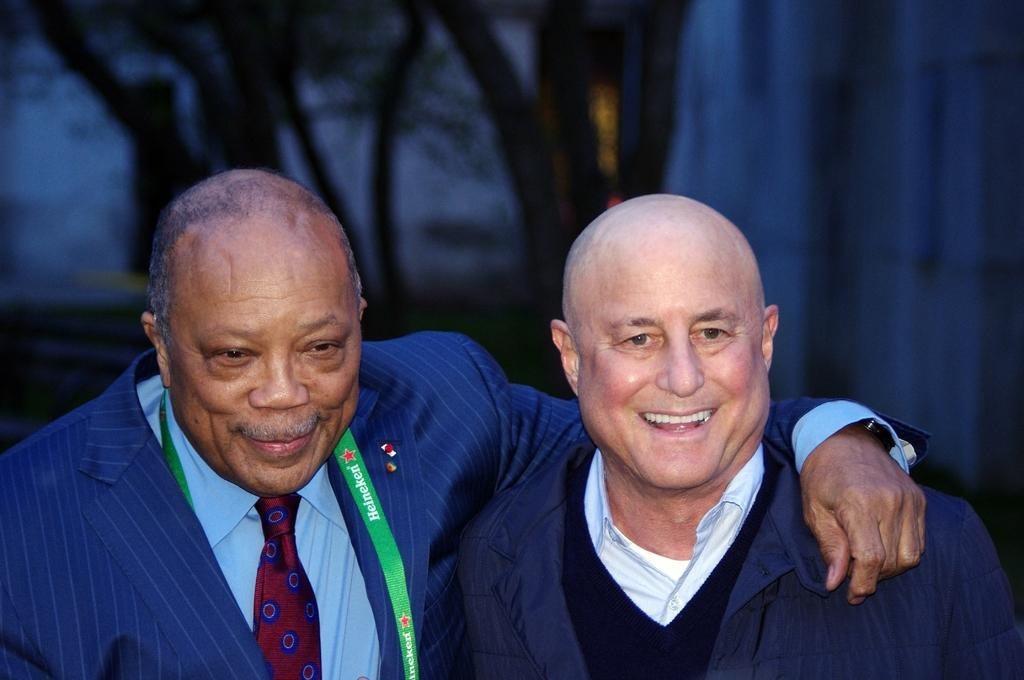How many people are in the image? There are two persons in the image. What are the two persons doing in the image? The two persons are standing. Can you describe the background of the image? The background of the image is blurred. How many dolls are sitting on the root in the image? There are no dolls or roots present in the image. 